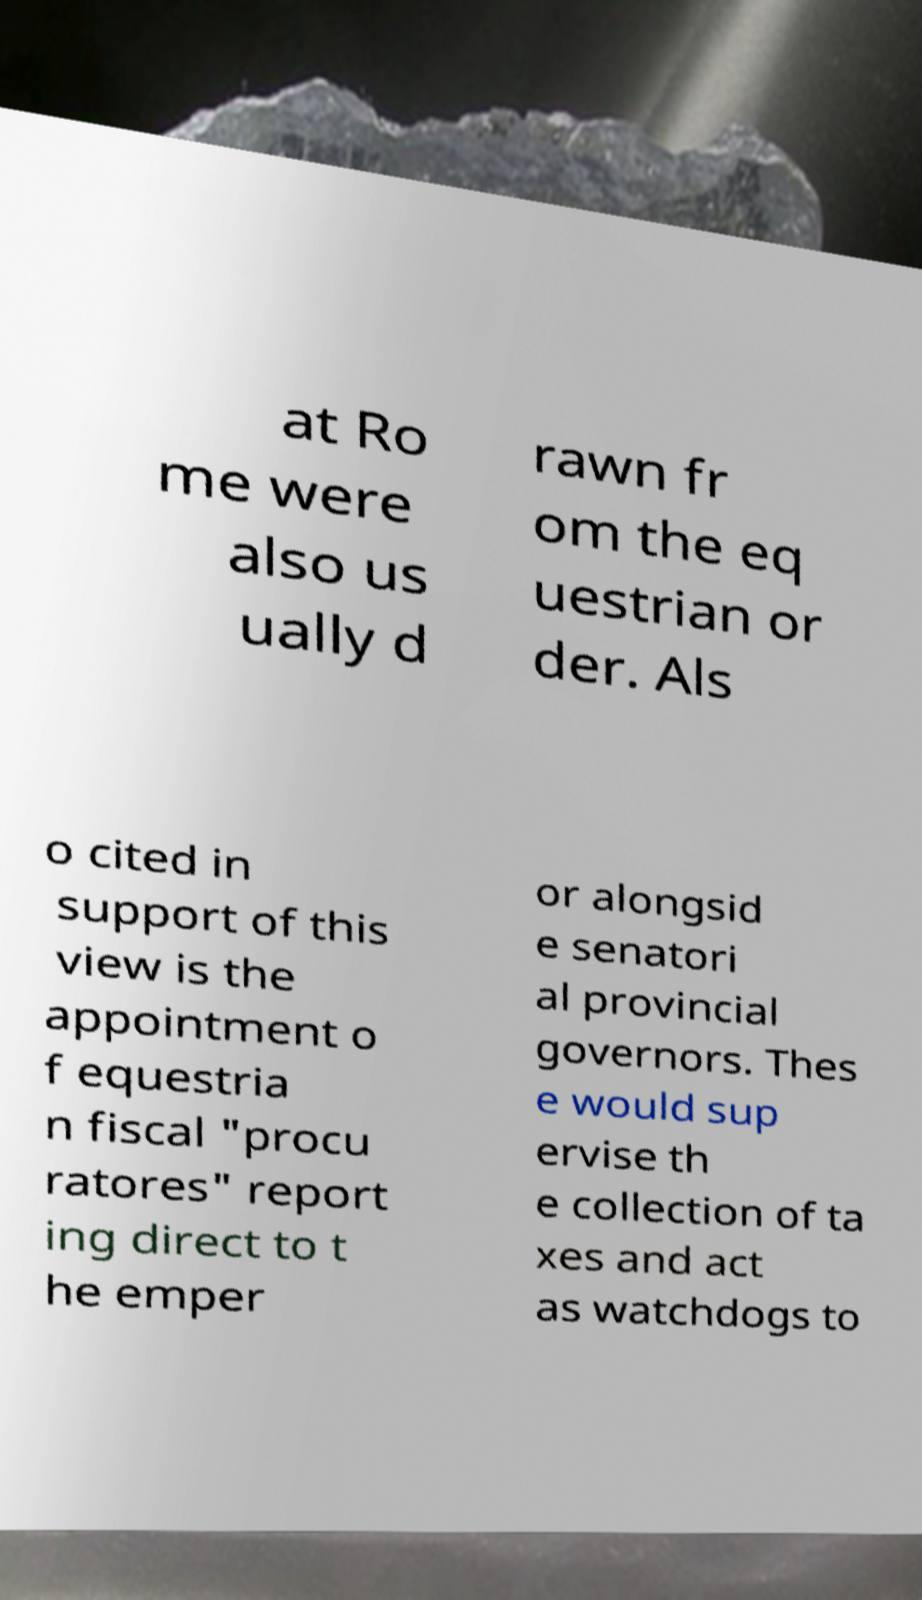Could you extract and type out the text from this image? at Ro me were also us ually d rawn fr om the eq uestrian or der. Als o cited in support of this view is the appointment o f equestria n fiscal "procu ratores" report ing direct to t he emper or alongsid e senatori al provincial governors. Thes e would sup ervise th e collection of ta xes and act as watchdogs to 